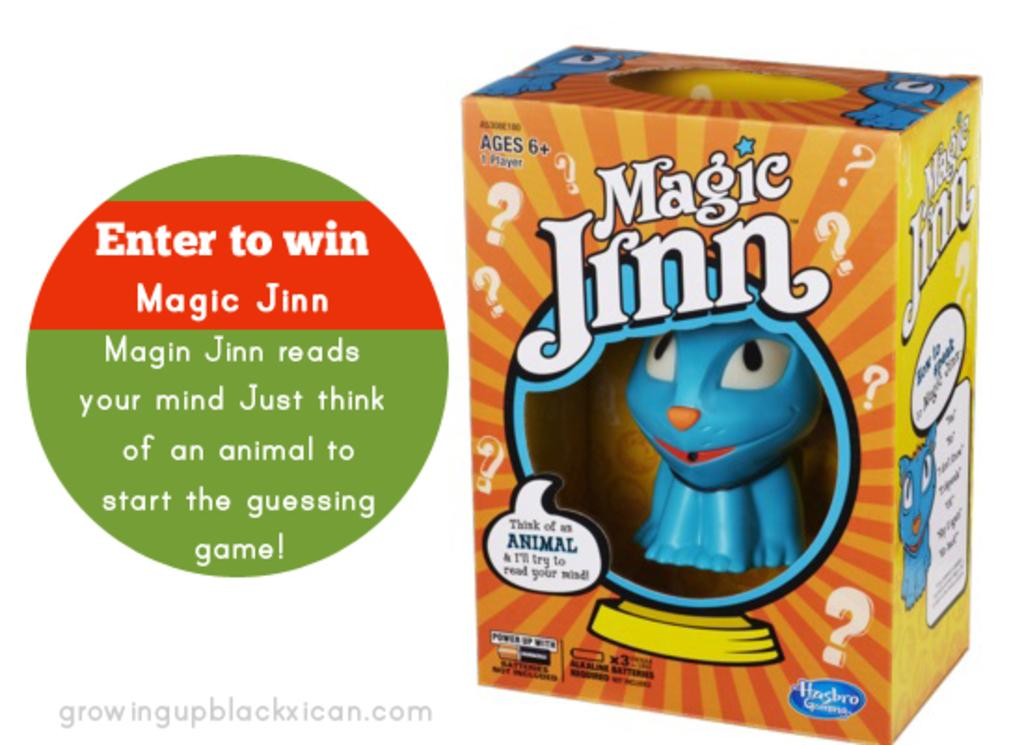What object is present in the image that is meant for play or amusement? There is a toy in the image. Where is the toy located in the image? The toy is placed in a carton. What else can be seen in the image besides the toy? There is text in the image. What type of engine can be seen powering the toy in the image? There is no engine present in the image, as the toy is not described as having any moving parts or requiring power. 